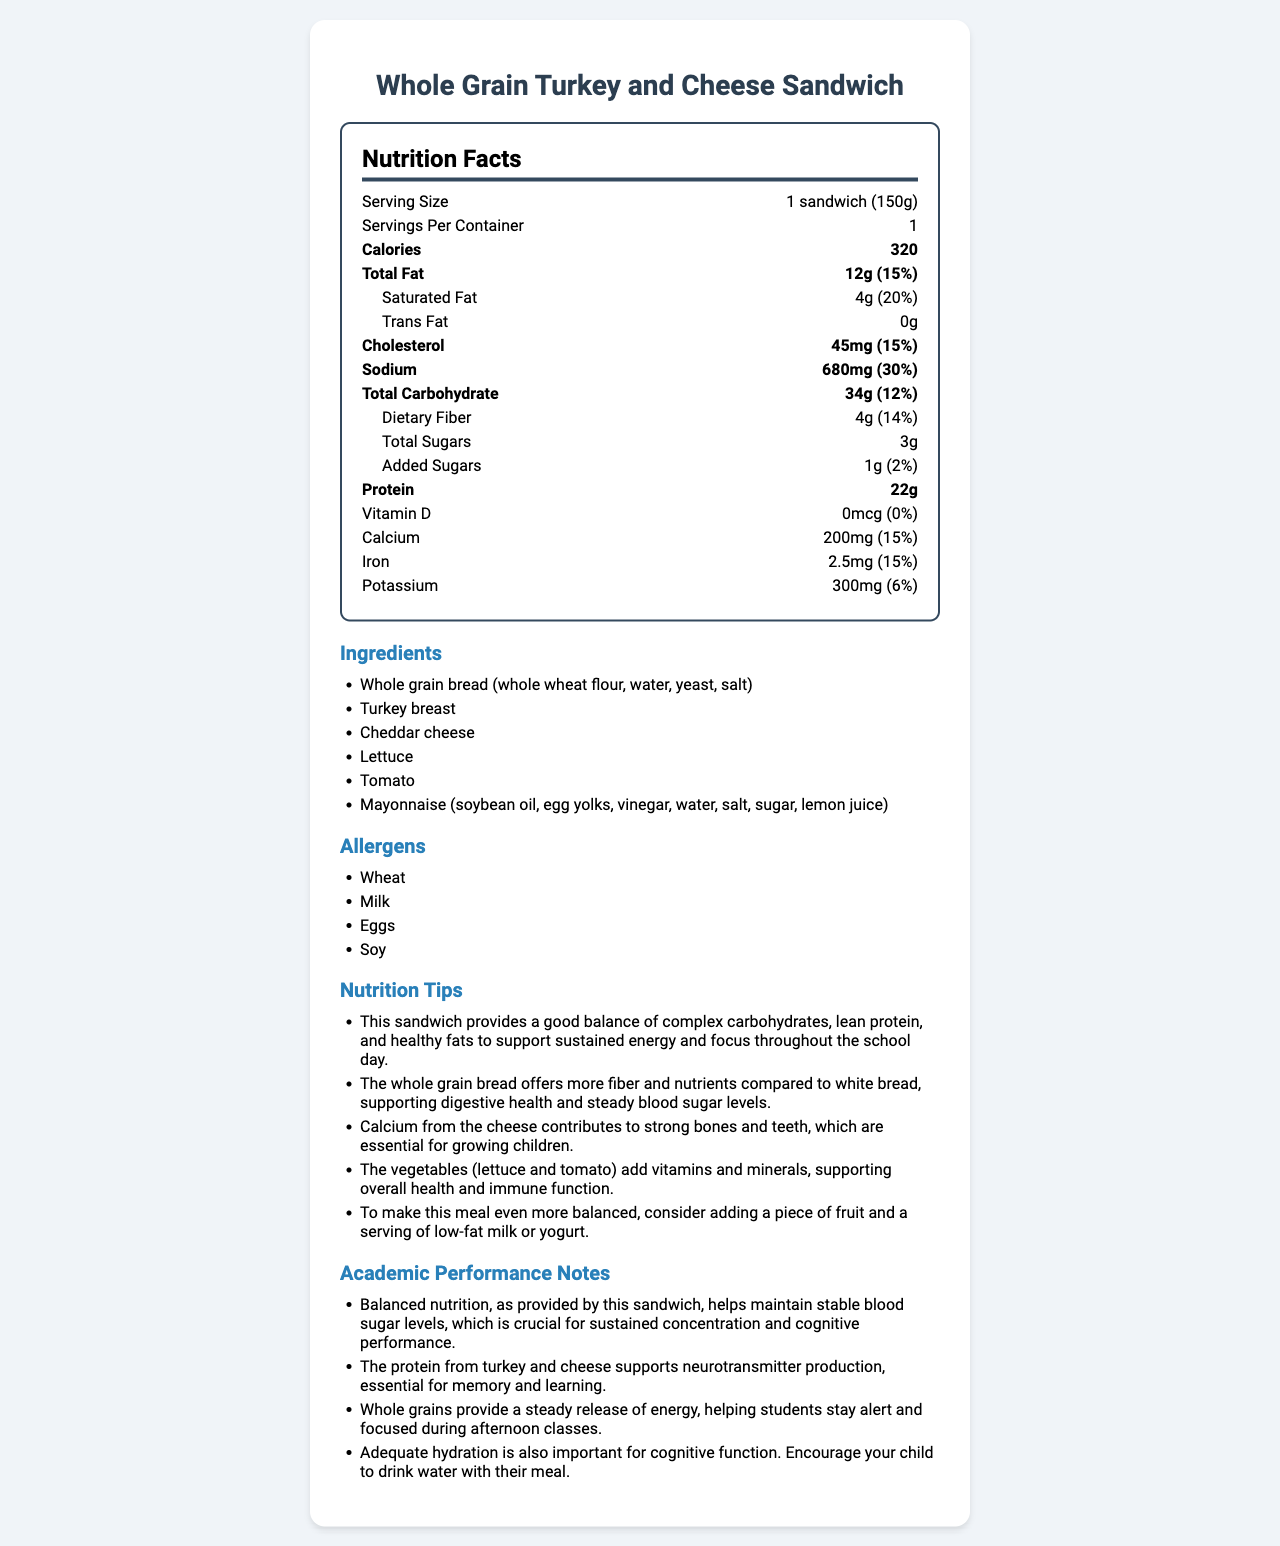who should avoid this sandwich if they have certain allergies? The allergens listed are wheat, milk, eggs, and soy, indicating that those with these allergies should avoid the sandwich.
Answer: People with allergies to wheat, milk, eggs, or soy how many calories are in one sandwich? The nutrition facts label states that one sandwich contains 320 calories.
Answer: 320 calories what is the serving size in grams? The serving size is specified as 1 sandwich (150g) on the nutrition facts label.
Answer: 150g how much sodium is in one serving of the sandwich? The nutrition facts label lists the sodium content as 680mg per serving.
Answer: 680mg what percentage of the daily value of calcium does this sandwich provide? The nutrition facts label shows that the sandwich provides 15% of the daily value for calcium.
Answer: 15% which nutrient supports sustained energy and focus? A. Vitamin D B. Vitamin C C. Carbohydrates D. Sodium The nutrition tips mention that whole grains provide a steady release of energy, supporting sustained energy and focus.
Answer: C. Carbohydrates how much protein is provided by one serving of the sandwich? The nutrition facts label indicates that one serving of the sandwich provides 22g of protein.
Answer: 22g what is the combined amount of saturated and trans fats in the sandwich? The nutrition facts state that the sandwich contains 4g of saturated fat and 0g of trans fat, so the combined amount is 4g.
Answer: 4g which ingredient does not contribute to allergies listed? A. Cheddar cheese B. Tomato C. Whole grain bread D. Mayonnaise The listed allergens include wheat (in whole grain bread), milk (in cheddar cheese), eggs, and soy (in mayonnaise). Tomato does not contribute to these allergens.
Answer: B. Tomato are there any added sugars in the sandwich? The nutrition facts label shows that there is 1g of added sugars.
Answer: Yes does this sandwich contain vitamin D? The nutrition facts label lists vitamin D as 0mcg with a 0% daily value.
Answer: No summarize the main idea of the document. The document aims to inform about the nutrition content and benefits of the sandwich while highlighting its potential impact on students' academic performance through balanced nutrition.
Answer: The document provides detailed nutrition information, ingredients, allergens, nutrition tips, and notes on academic performance for a Whole Grain Turkey and Cheese Sandwich. It emphasizes the importance of balanced nutrition for sustaining energy and focus in school children. what is the specific type of fat recommended to look out for to understand the impact on heart health? The document does not provide specific advice on which types of fat to look out for in relation to heart health.
Answer: Cannot be determined 